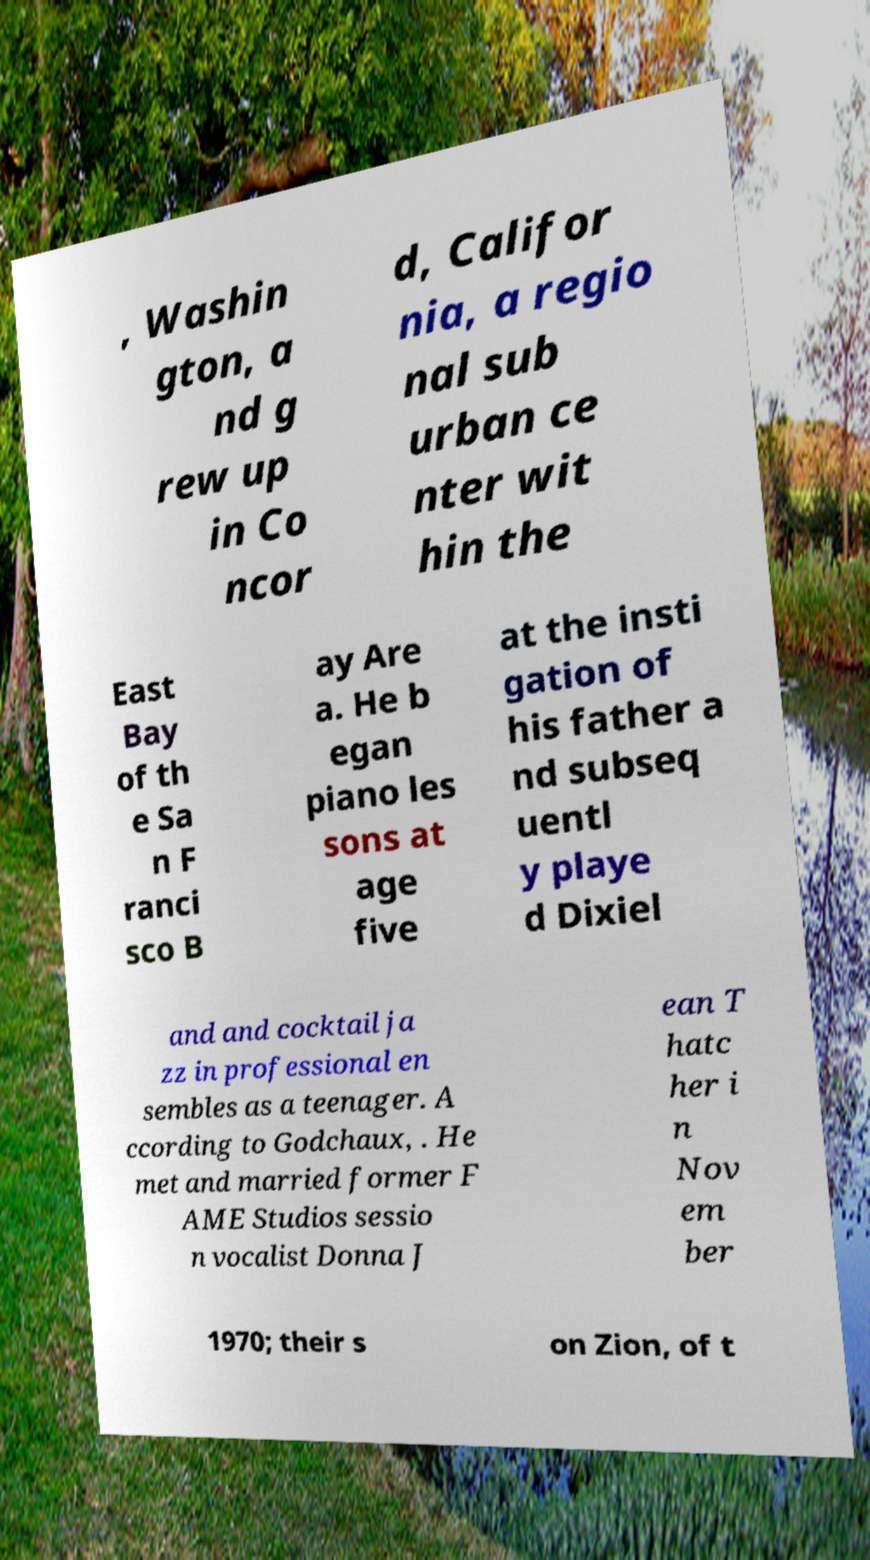What messages or text are displayed in this image? I need them in a readable, typed format. , Washin gton, a nd g rew up in Co ncor d, Califor nia, a regio nal sub urban ce nter wit hin the East Bay of th e Sa n F ranci sco B ay Are a. He b egan piano les sons at age five at the insti gation of his father a nd subseq uentl y playe d Dixiel and and cocktail ja zz in professional en sembles as a teenager. A ccording to Godchaux, . He met and married former F AME Studios sessio n vocalist Donna J ean T hatc her i n Nov em ber 1970; their s on Zion, of t 